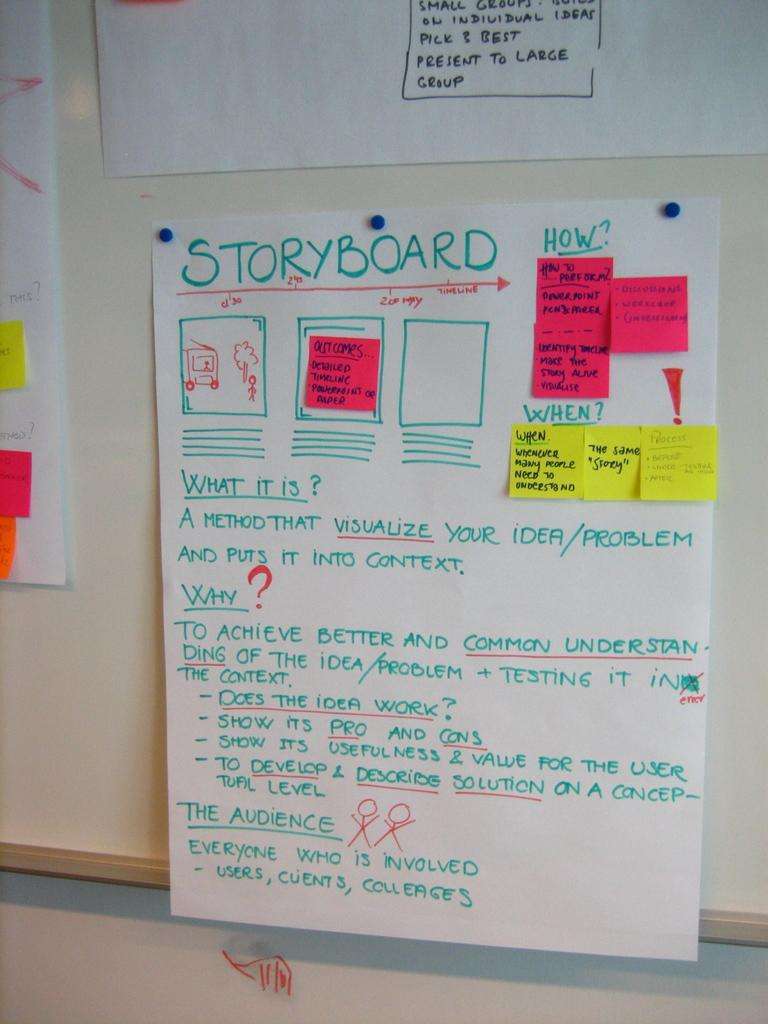<image>
Write a terse but informative summary of the picture. A bulletin board with Storyboard flow chart example pinned to it. 